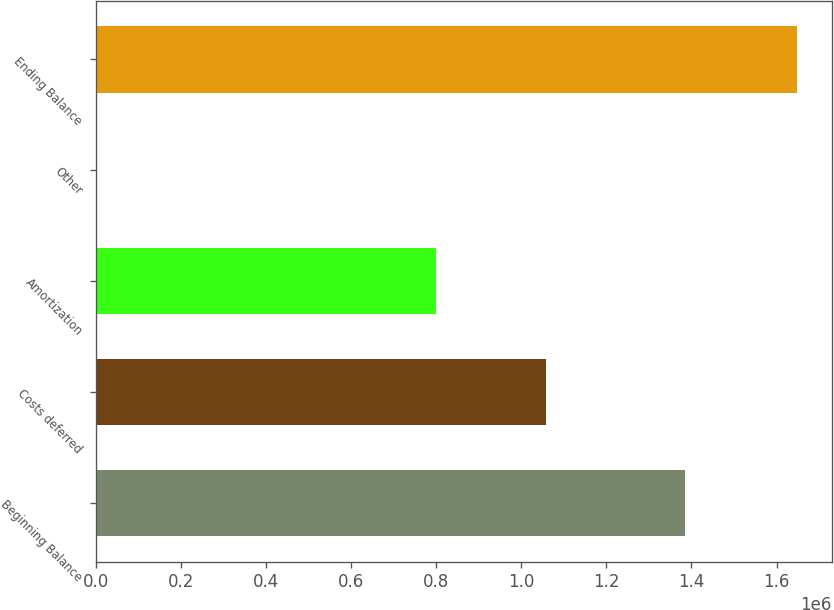Convert chart. <chart><loc_0><loc_0><loc_500><loc_500><bar_chart><fcel>Beginning Balance<fcel>Costs deferred<fcel>Amortization<fcel>Other<fcel>Ending Balance<nl><fcel>1.38483e+06<fcel>1.05895e+06<fcel>798985<fcel>2858<fcel>1.64765e+06<nl></chart> 